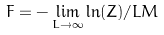Convert formula to latex. <formula><loc_0><loc_0><loc_500><loc_500>F = - \lim _ { L \to \infty } \ln ( Z ) / L M</formula> 